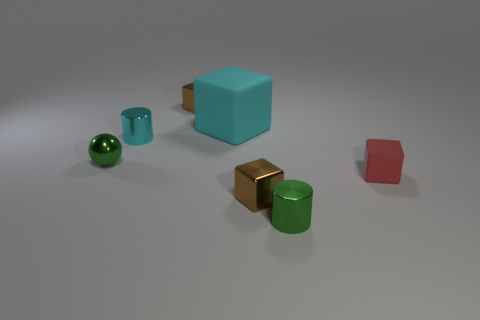There is a large rubber thing; does it have the same color as the small metal cylinder to the left of the green cylinder?
Keep it short and to the point. Yes. Are there any other things that have the same size as the cyan rubber object?
Provide a short and direct response. No. There is a shiny cylinder that is on the right side of the rubber block behind the tiny red thing; how big is it?
Offer a very short reply. Small. How many objects are either red things or tiny metal blocks that are behind the tiny rubber object?
Ensure brevity in your answer.  2. There is a tiny brown shiny object in front of the cyan metal object; is its shape the same as the cyan metal object?
Provide a short and direct response. No. How many tiny green metallic balls are behind the tiny block that is behind the tiny green metallic sphere that is behind the tiny red thing?
Your answer should be very brief. 0. What number of things are either cyan blocks or cylinders?
Offer a very short reply. 3. There is a small red matte thing; is its shape the same as the small green metallic thing that is on the right side of the cyan rubber cube?
Your response must be concise. No. What shape is the tiny brown object that is on the right side of the big object?
Your answer should be compact. Cube. Does the tiny matte object have the same shape as the big matte thing?
Your answer should be very brief. Yes. 